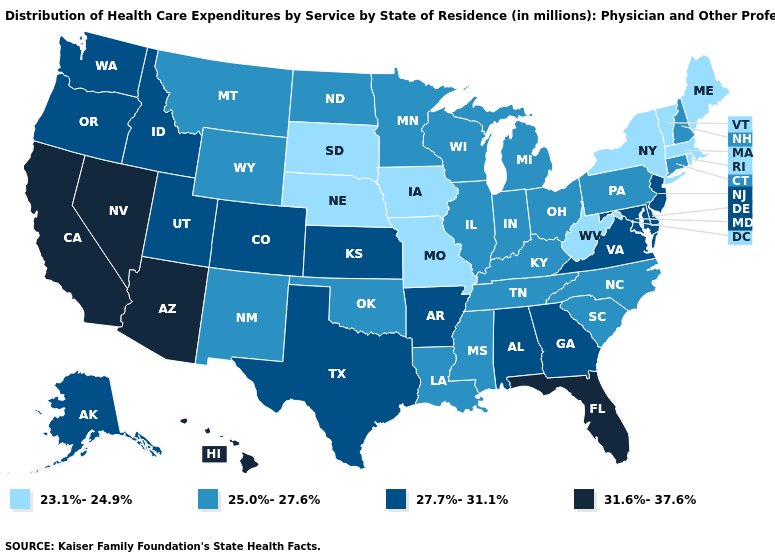Among the states that border Maine , which have the lowest value?
Be succinct. New Hampshire. Does Nevada have the same value as California?
Answer briefly. Yes. Among the states that border Colorado , does Arizona have the highest value?
Write a very short answer. Yes. Is the legend a continuous bar?
Write a very short answer. No. What is the lowest value in the USA?
Give a very brief answer. 23.1%-24.9%. Does North Carolina have the highest value in the USA?
Keep it brief. No. What is the value of South Carolina?
Quick response, please. 25.0%-27.6%. Name the states that have a value in the range 31.6%-37.6%?
Give a very brief answer. Arizona, California, Florida, Hawaii, Nevada. What is the value of Arkansas?
Short answer required. 27.7%-31.1%. Does the map have missing data?
Answer briefly. No. Does Illinois have the same value as Alabama?
Short answer required. No. Does Alaska have a higher value than Utah?
Keep it brief. No. Does Mississippi have the lowest value in the South?
Concise answer only. No. Among the states that border Kentucky , which have the highest value?
Quick response, please. Virginia. Name the states that have a value in the range 27.7%-31.1%?
Keep it brief. Alabama, Alaska, Arkansas, Colorado, Delaware, Georgia, Idaho, Kansas, Maryland, New Jersey, Oregon, Texas, Utah, Virginia, Washington. 